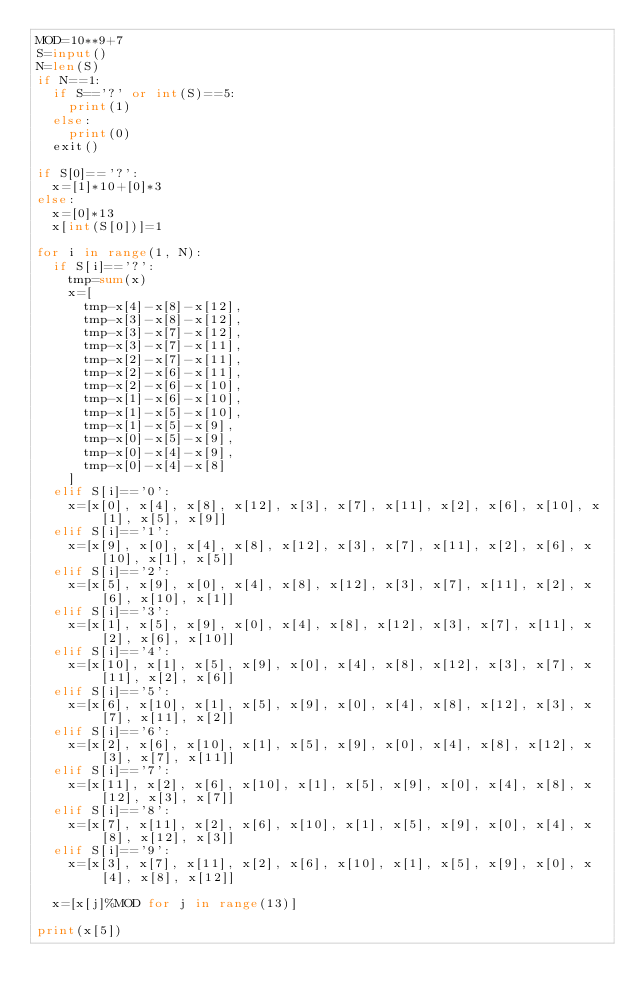<code> <loc_0><loc_0><loc_500><loc_500><_Python_>MOD=10**9+7
S=input()
N=len(S)
if N==1:
  if S=='?' or int(S)==5:
    print(1)
  else:
    print(0)
  exit()

if S[0]=='?':
  x=[1]*10+[0]*3
else:
  x=[0]*13
  x[int(S[0])]=1

for i in range(1, N):
  if S[i]=='?':
    tmp=sum(x)
    x=[
      tmp-x[4]-x[8]-x[12],
      tmp-x[3]-x[8]-x[12],
      tmp-x[3]-x[7]-x[12],
      tmp-x[3]-x[7]-x[11],
      tmp-x[2]-x[7]-x[11],
      tmp-x[2]-x[6]-x[11],
      tmp-x[2]-x[6]-x[10],
      tmp-x[1]-x[6]-x[10],
      tmp-x[1]-x[5]-x[10],
      tmp-x[1]-x[5]-x[9],
      tmp-x[0]-x[5]-x[9],
      tmp-x[0]-x[4]-x[9],
      tmp-x[0]-x[4]-x[8]
    ]
  elif S[i]=='0':
    x=[x[0], x[4], x[8], x[12], x[3], x[7], x[11], x[2], x[6], x[10], x[1], x[5], x[9]]
  elif S[i]=='1':
    x=[x[9], x[0], x[4], x[8], x[12], x[3], x[7], x[11], x[2], x[6], x[10], x[1], x[5]]
  elif S[i]=='2':
    x=[x[5], x[9], x[0], x[4], x[8], x[12], x[3], x[7], x[11], x[2], x[6], x[10], x[1]]
  elif S[i]=='3':
    x=[x[1], x[5], x[9], x[0], x[4], x[8], x[12], x[3], x[7], x[11], x[2], x[6], x[10]]
  elif S[i]=='4':
    x=[x[10], x[1], x[5], x[9], x[0], x[4], x[8], x[12], x[3], x[7], x[11], x[2], x[6]]
  elif S[i]=='5':
    x=[x[6], x[10], x[1], x[5], x[9], x[0], x[4], x[8], x[12], x[3], x[7], x[11], x[2]]
  elif S[i]=='6':
    x=[x[2], x[6], x[10], x[1], x[5], x[9], x[0], x[4], x[8], x[12], x[3], x[7], x[11]]
  elif S[i]=='7':
    x=[x[11], x[2], x[6], x[10], x[1], x[5], x[9], x[0], x[4], x[8], x[12], x[3], x[7]]
  elif S[i]=='8':
    x=[x[7], x[11], x[2], x[6], x[10], x[1], x[5], x[9], x[0], x[4], x[8], x[12], x[3]]
  elif S[i]=='9':
    x=[x[3], x[7], x[11], x[2], x[6], x[10], x[1], x[5], x[9], x[0], x[4], x[8], x[12]]
    
  x=[x[j]%MOD for j in range(13)]

print(x[5])</code> 